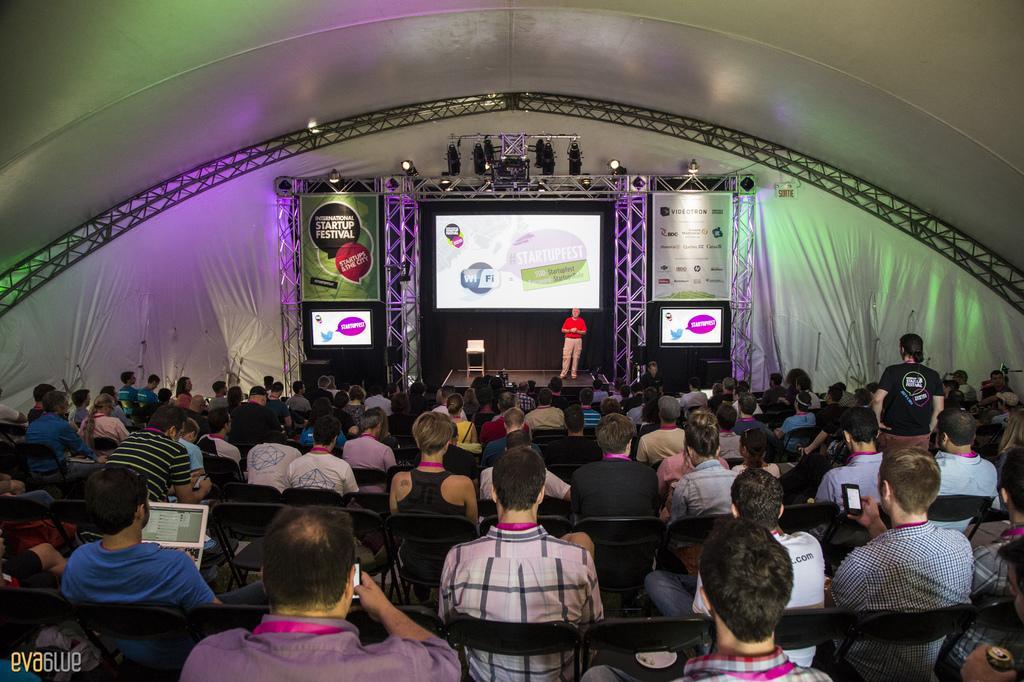Can you describe this image briefly? This image is taken indoors. At the top of the image there is a roof. In the background there is a cloth which is white in color. There are a few iron bars. There is a screen. There are many boards with text on them. There are two televisions. There are a few lights. In the middle of the image a man is standing on the dais and there is a chair on the dais. In the middle of the image many people are sitting on the chairs and a few are holding devices in their hands and a man is standing. 